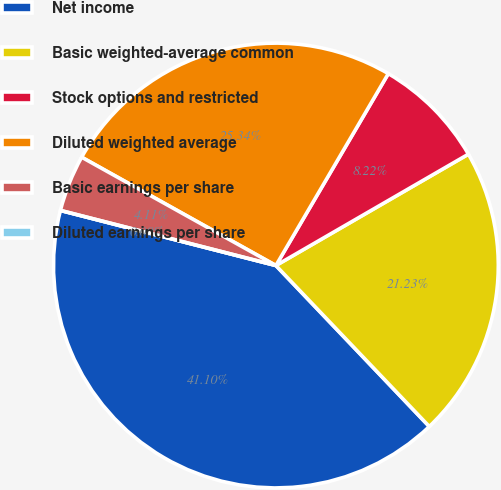<chart> <loc_0><loc_0><loc_500><loc_500><pie_chart><fcel>Net income<fcel>Basic weighted-average common<fcel>Stock options and restricted<fcel>Diluted weighted average<fcel>Basic earnings per share<fcel>Diluted earnings per share<nl><fcel>41.1%<fcel>21.23%<fcel>8.22%<fcel>25.34%<fcel>4.11%<fcel>0.0%<nl></chart> 